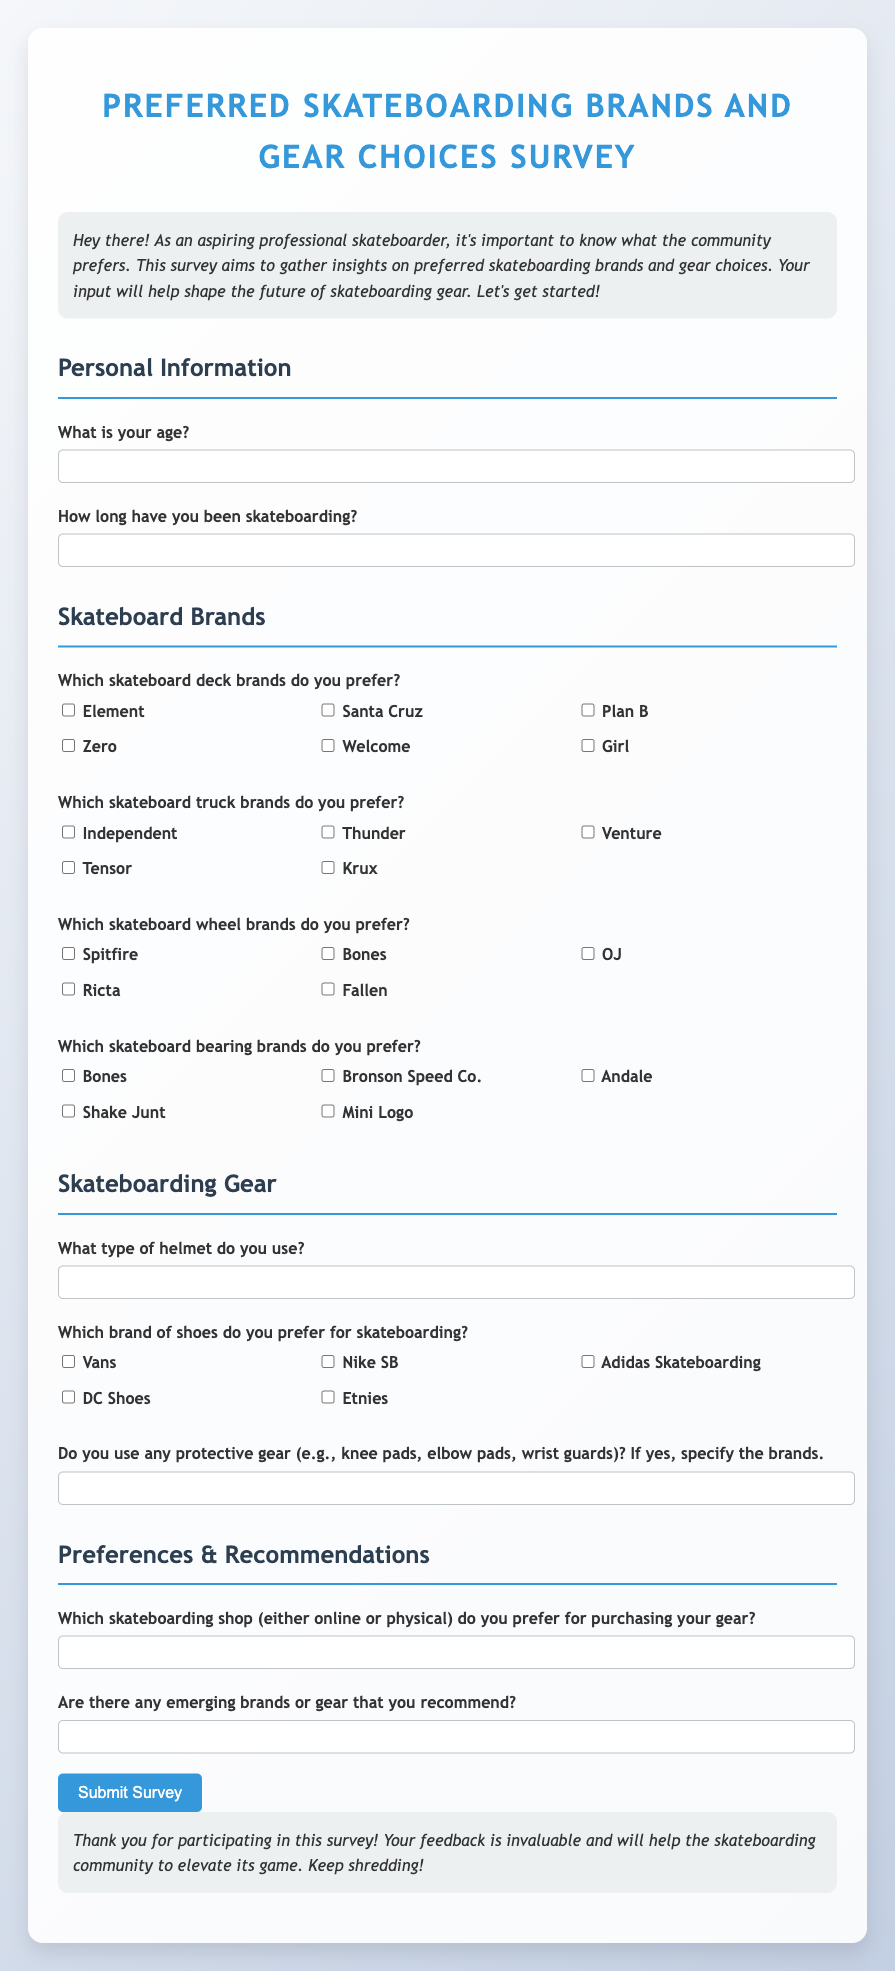What is the title of the survey? The title is stated at the top of the survey in a prominent position.
Answer: Preferred Skateboarding Brands and Gear Choices Survey What is the maximum width for the container? The document specifies the styling for the container which indicates the maximum width for display purposes.
Answer: 800px What is the age input type in the survey? The survey indicates the type of input expected for the age question which can be seen in the form.
Answer: number Which brand is listed as a skateboard deck option? The survey provides multiple choices for skateboard deck brands, one of which is shown in the list.
Answer: Element Which type of helmet does the user have to specify? The survey includes a question that specifically asks about the type of helmet used, which is mentioned explicitly.
Answer: type of helmet What is one of the shoe brands mentioned for skateboarding? The survey lists various shoe brand options, and one can be seen prominently.
Answer: Vans What are participants asked to provide in the recommendations section? The survey asks respondents for specific input regarding suggestions for new brands or gear, indicated in the question.
Answer: emerging brands or gear How many truck brands are presented in the survey? The survey includes a list of truck brands, the total number can be counted directly from the displayed options.
Answer: 5 What type of gear is mentioned alongside knee pads and elbow pads? The survey includes protective gear examples, prompting for details in the response.
Answer: wrist guards 